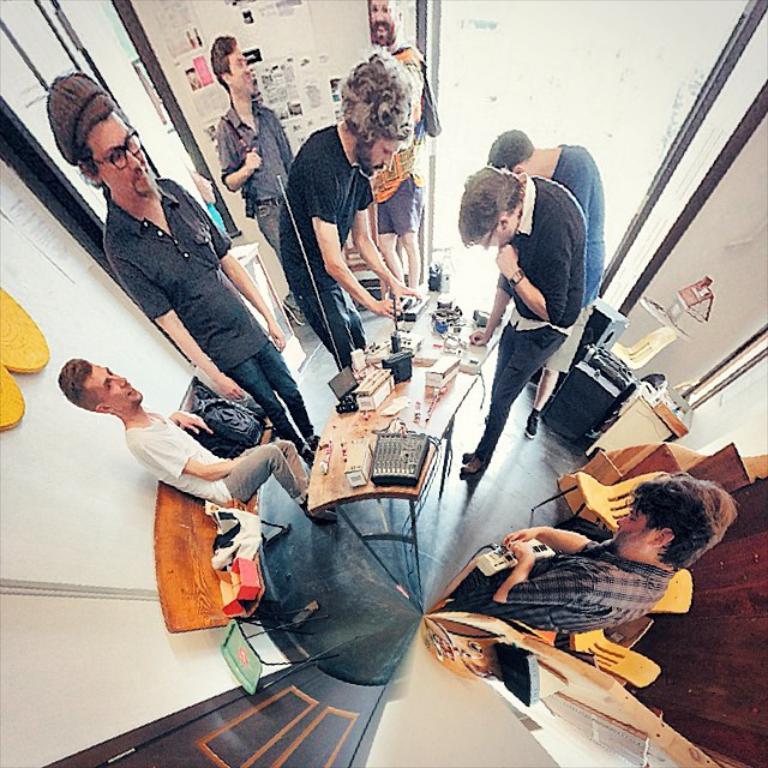Please provide a concise description of this image. In the picture I can see a few people standing on the floor. There is a man sitting on the wooden bench and he is on the left side. There is a man on the right side is holding an extension box in his hands. In the background, I can see two men and they are smiling. It is looking like a wooden door on the bottom left side of the picture. I can see the wooden table on the floor and there are electronic objects on the table. 